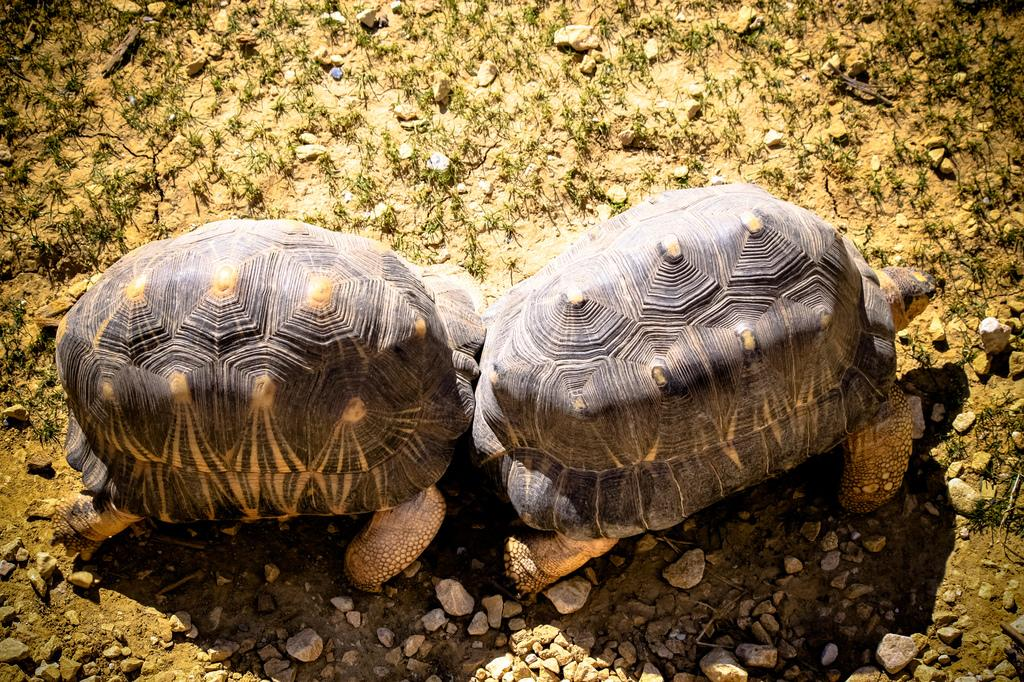How many tortoises are present in the image? There are two tortoises in the image. Where are the tortoises located? The tortoises are on a path. What type of iron is being used by the tortoises in the image? There is no iron present in the image; it features two tortoises on a path. Can you see a hat on either of the tortoises in the image? No, there are no hats on the tortoises in the image. 